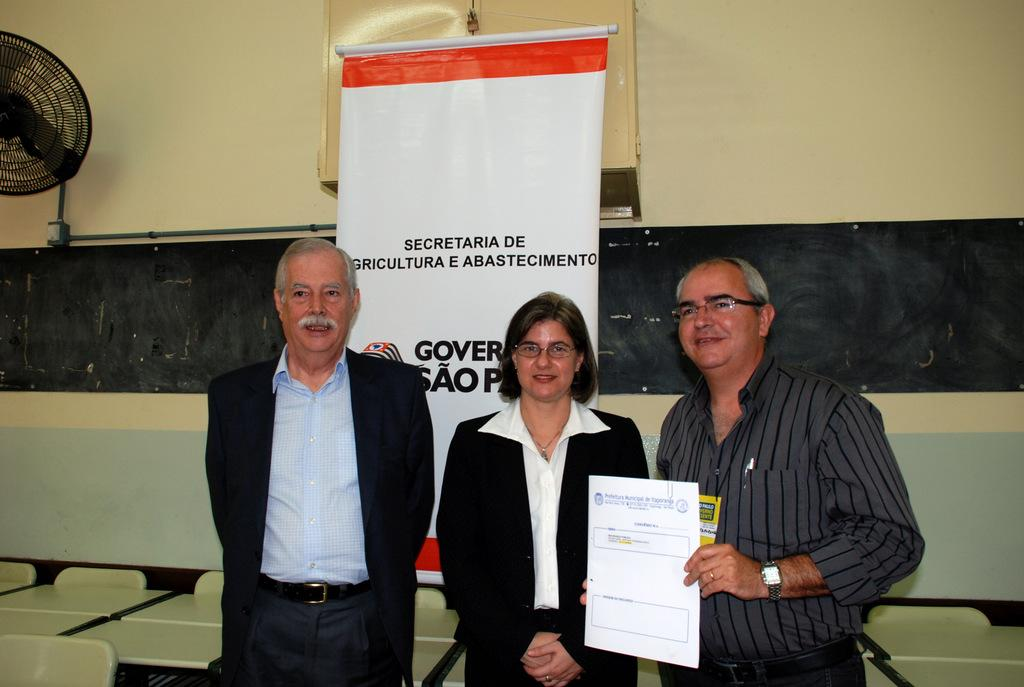How many people are in the foreground of the picture? There are three people standing in the foreground of the picture. What is located behind the people? There are tables behind the people. What can be seen hanging or displayed in the image? There is a banner visible in the image. What is present at the top of the image? At the top of the image, there is a fan, a pipe, a window, and a wall. What type of corn can be seen growing in the wilderness in the image? There is no corn or wilderness present in the image. 